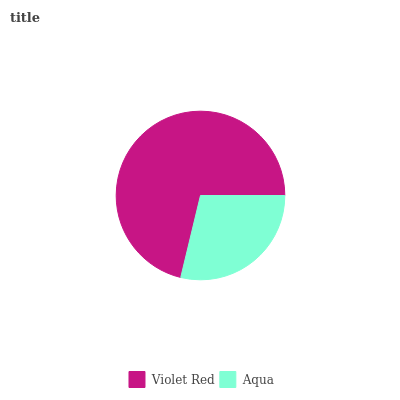Is Aqua the minimum?
Answer yes or no. Yes. Is Violet Red the maximum?
Answer yes or no. Yes. Is Aqua the maximum?
Answer yes or no. No. Is Violet Red greater than Aqua?
Answer yes or no. Yes. Is Aqua less than Violet Red?
Answer yes or no. Yes. Is Aqua greater than Violet Red?
Answer yes or no. No. Is Violet Red less than Aqua?
Answer yes or no. No. Is Violet Red the high median?
Answer yes or no. Yes. Is Aqua the low median?
Answer yes or no. Yes. Is Aqua the high median?
Answer yes or no. No. Is Violet Red the low median?
Answer yes or no. No. 